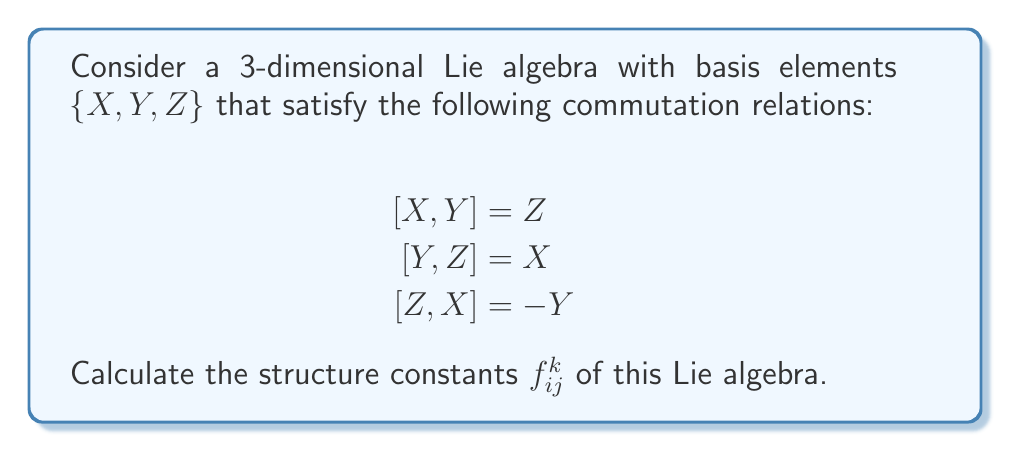Help me with this question. To calculate the structure constants of a Lie algebra, we need to express the commutation relations in terms of the structure constants. The general form of a commutation relation is:

$$[e_i, e_j] = \sum_k f_{ij}^k e_k$$

where $e_i$, $e_j$, and $e_k$ are basis elements, and $f_{ij}^k$ are the structure constants.

For our given Lie algebra:

1. $[X,Y] = Z$ implies $f_{12}^3 = 1$ (and $f_{21}^3 = -1$ due to antisymmetry)
2. $[Y,Z] = X$ implies $f_{23}^1 = 1$ (and $f_{32}^1 = -1$)
3. $[Z,X] = -Y$ implies $f_{31}^2 = -1$ (and $f_{13}^2 = 1$)

All other structure constants are zero.

We can represent the structure constants in a 3x3x3 array, where $f_{ij}^k$ is the element in the $k$-th plane, $i$-th row, and $j$-th column:

$$f_{ij}^1 = \begin{pmatrix}
0 & 0 & -1 \\
0 & 0 & 1 \\
1 & -1 & 0
\end{pmatrix}$$

$$f_{ij}^2 = \begin{pmatrix}
0 & -1 & 1 \\
1 & 0 & 0 \\
-1 & 0 & 0
\end{pmatrix}$$

$$f_{ij}^3 = \begin{pmatrix}
0 & 1 & 0 \\
-1 & 0 & 0 \\
0 & 0 & 0
\end{pmatrix}$$
Answer: The non-zero structure constants are:
$f_{12}^3 = 1$, $f_{21}^3 = -1$
$f_{23}^1 = 1$, $f_{32}^1 = -1$
$f_{31}^2 = -1$, $f_{13}^2 = 1$
All other $f_{ij}^k = 0$ 